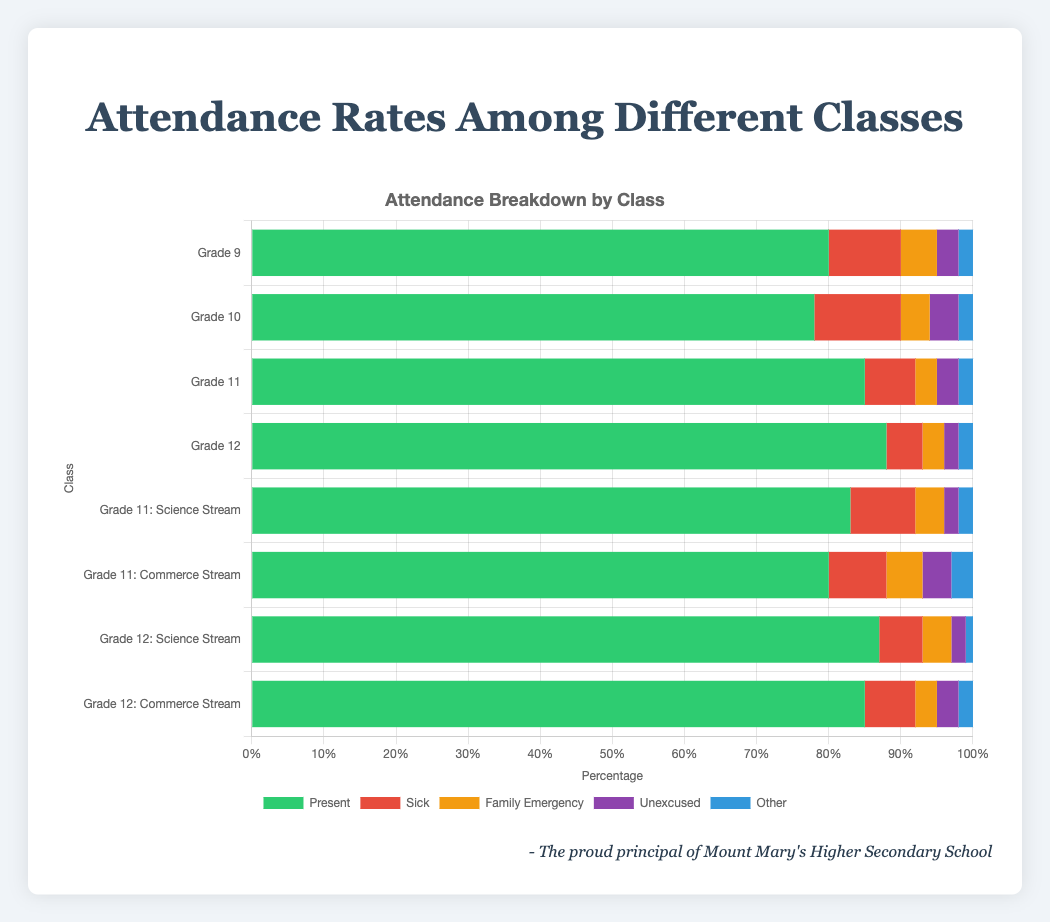Which class has the highest percentage of students present? Grade 12 has the highest percentage of students present. By looking at the stacked bar chart, Grade 12 shows the highest value in the green segment, which represents the percentage of students present.
Answer: Grade 12 Which class has the highest number of sick absences? By observing the sections in red for each class (which represent sick absences), Grade 10 has the highest number of sick absences at 12%.
Answer: Grade 10 What is the total percentage of absences (all types) for Grade 11: Commerce Stream? To find the total percentage of absences for Grade 11: Commerce Stream, we need to add the percentages for Sick (8%), Family Emergency (5%), Unexcused (4%), and Other (3%). Performing the addition gives us 8 + 5 + 4 + 3 = 20%.
Answer: 20% Which class has the smallest percentage of unexcused absences? The class with the smallest percentage of unexcused absences is Grade 12 and Grade 12: Science Stream, both having an unexcused absence percentage of 2%, indicated by the smallest segments in purple.
Answer: Grade 12 and Grade 12: Science Stream Compare the total percentage of absences between Grade 9 and Grade 10. Which class has a higher percentage? We add the absences for Grade 9: Sick (10%), Family Emergency (5%), Unexcused (3%), and Other (2%) to get 20%. For Grade 10, we add: Sick (12%), Family Emergency (4%), Unexcused (4%), and Other (2%) to get 22%. Grade 10 has a higher percentage of total absences by 2%.
Answer: Grade 10 Which class has the highest percentage of family emergencies? By looking at the orange segments representing family emergencies, Grade 9: Commerce Stream and Grade 11: Commerce Stream both have the highest percentage at 5%.
Answer: Grade 11: Commerce Stream and Grade 9: Commerce Stream Which two classes have equal percentages of students present? The classes Grade 11: Commerce Stream and Grade 9 both have 80% of students present, as indicated by the equal lengths of the green segments in the respective bars.
Answer: Grade 11: Commerce Stream and Grade 9 